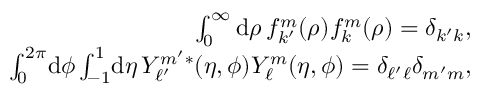<formula> <loc_0><loc_0><loc_500><loc_500>\begin{array} { r } { \int _ { 0 } ^ { \infty } d \rho \, f _ { k ^ { \prime } } ^ { m } ( \rho ) f _ { k } ^ { m } ( \rho ) = \delta _ { k ^ { \prime } k } , } \\ { \int _ { 0 } ^ { 2 \pi } \, d \phi \int _ { - 1 } ^ { 1 } \, d \eta \, Y _ { \ell ^ { \prime } } ^ { m ^ { \prime } * } ( \eta , \phi ) Y _ { \ell } ^ { m } ( \eta , \phi ) = \delta _ { \ell ^ { \prime } \ell } \delta _ { m ^ { \prime } m } , } \end{array}</formula> 